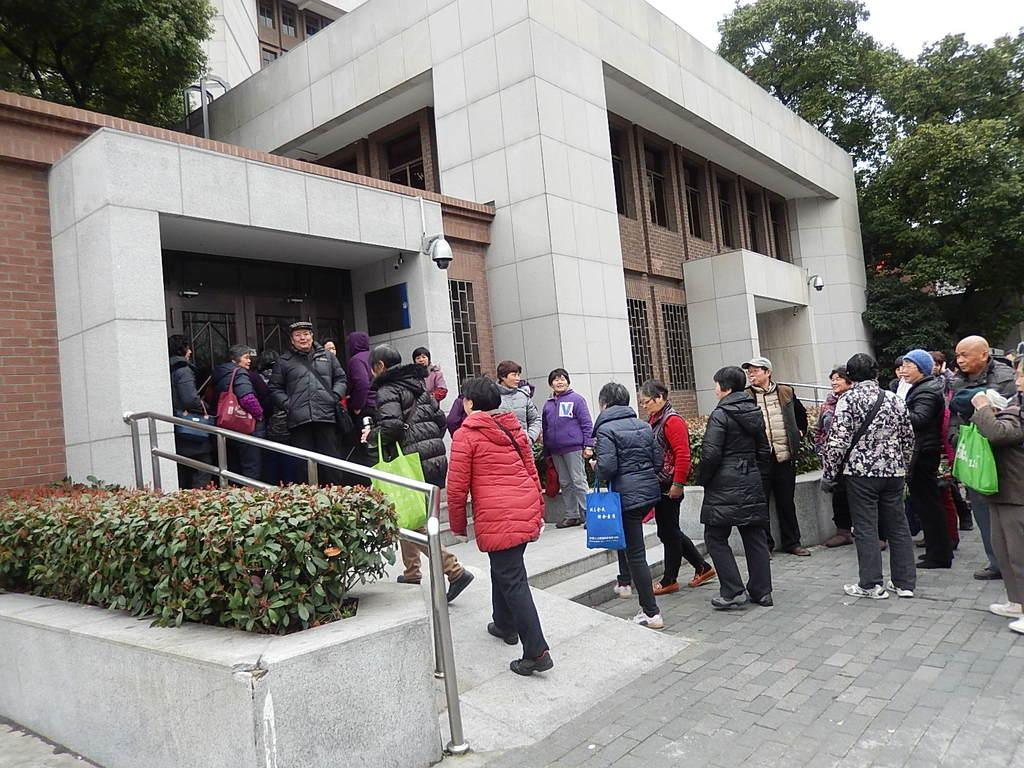How many persons are in the image? There are persons in the image, but the exact number is not specified. What are the persons wearing in the image? The persons are wearing jackets in the image. What are the persons carrying in the image? The persons are carrying bags in the image. What is the surface on which the persons are standing in the image? The persons are standing on the ground in the image. What can be seen in the background of the image? There is a building and trees in the background of the image. What type of light can be seen illuminating the garden in the image? There is no garden or light present in the image; it features persons standing on the ground with a building and trees in the background. 